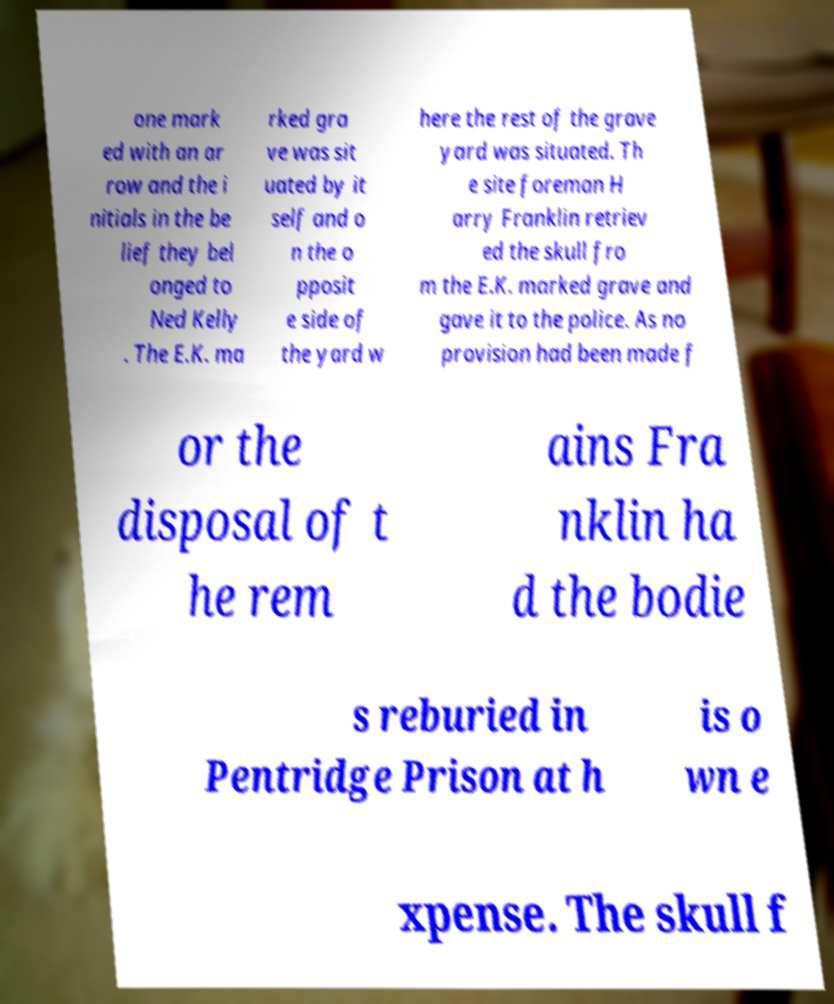Please identify and transcribe the text found in this image. one mark ed with an ar row and the i nitials in the be lief they bel onged to Ned Kelly . The E.K. ma rked gra ve was sit uated by it self and o n the o pposit e side of the yard w here the rest of the grave yard was situated. Th e site foreman H arry Franklin retriev ed the skull fro m the E.K. marked grave and gave it to the police. As no provision had been made f or the disposal of t he rem ains Fra nklin ha d the bodie s reburied in Pentridge Prison at h is o wn e xpense. The skull f 